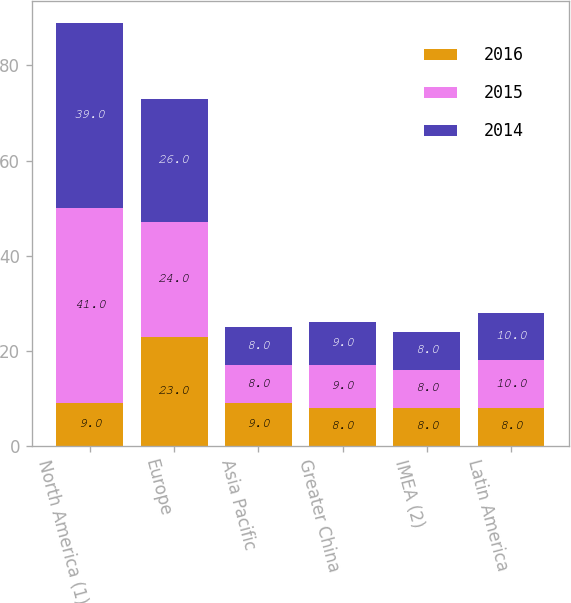<chart> <loc_0><loc_0><loc_500><loc_500><stacked_bar_chart><ecel><fcel>North America (1)<fcel>Europe<fcel>Asia Pacific<fcel>Greater China<fcel>IMEA (2)<fcel>Latin America<nl><fcel>2016<fcel>9<fcel>23<fcel>9<fcel>8<fcel>8<fcel>8<nl><fcel>2015<fcel>41<fcel>24<fcel>8<fcel>9<fcel>8<fcel>10<nl><fcel>2014<fcel>39<fcel>26<fcel>8<fcel>9<fcel>8<fcel>10<nl></chart> 